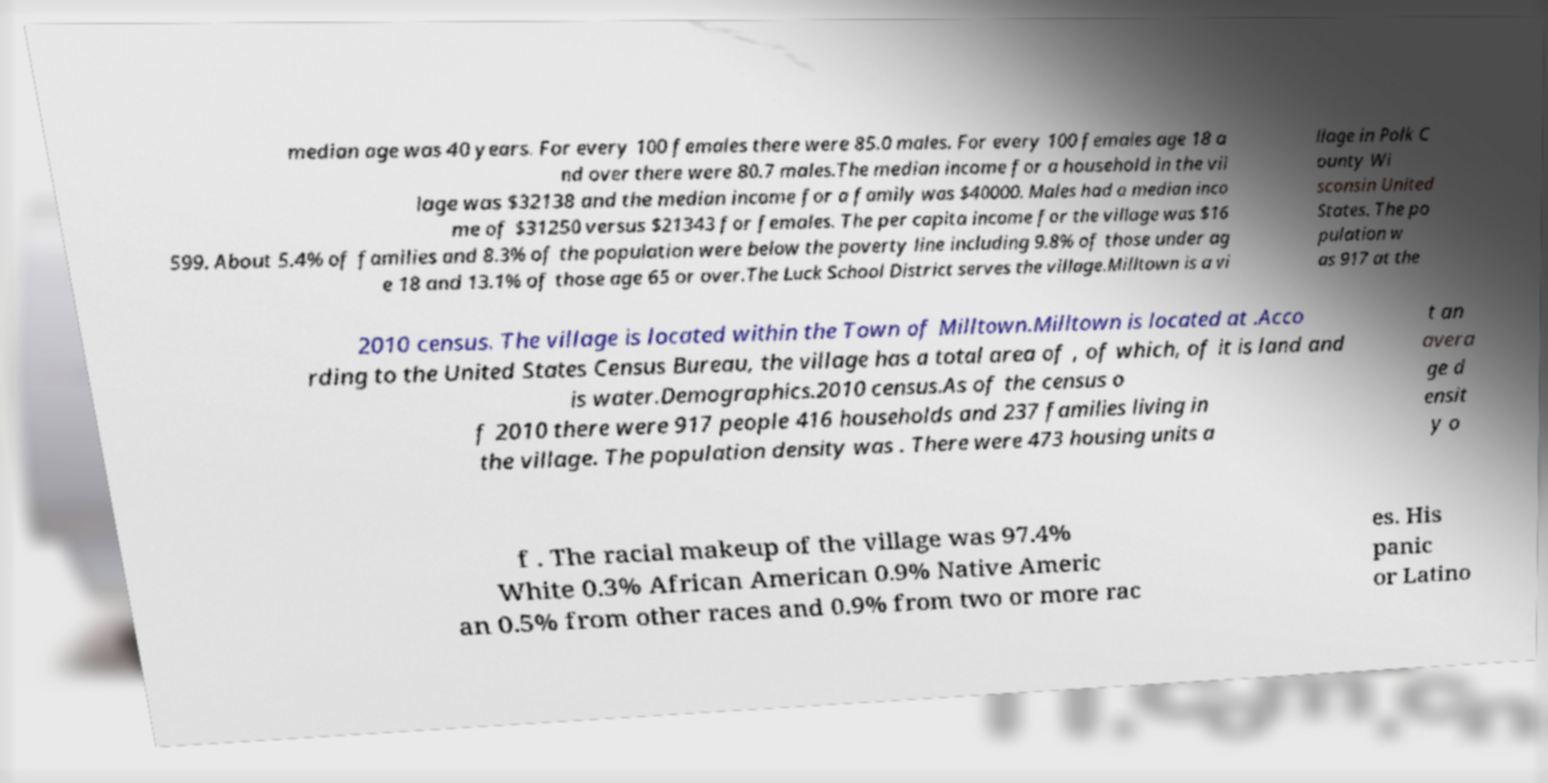For documentation purposes, I need the text within this image transcribed. Could you provide that? median age was 40 years. For every 100 females there were 85.0 males. For every 100 females age 18 a nd over there were 80.7 males.The median income for a household in the vil lage was $32138 and the median income for a family was $40000. Males had a median inco me of $31250 versus $21343 for females. The per capita income for the village was $16 599. About 5.4% of families and 8.3% of the population were below the poverty line including 9.8% of those under ag e 18 and 13.1% of those age 65 or over.The Luck School District serves the village.Milltown is a vi llage in Polk C ounty Wi sconsin United States. The po pulation w as 917 at the 2010 census. The village is located within the Town of Milltown.Milltown is located at .Acco rding to the United States Census Bureau, the village has a total area of , of which, of it is land and is water.Demographics.2010 census.As of the census o f 2010 there were 917 people 416 households and 237 families living in the village. The population density was . There were 473 housing units a t an avera ge d ensit y o f . The racial makeup of the village was 97.4% White 0.3% African American 0.9% Native Americ an 0.5% from other races and 0.9% from two or more rac es. His panic or Latino 